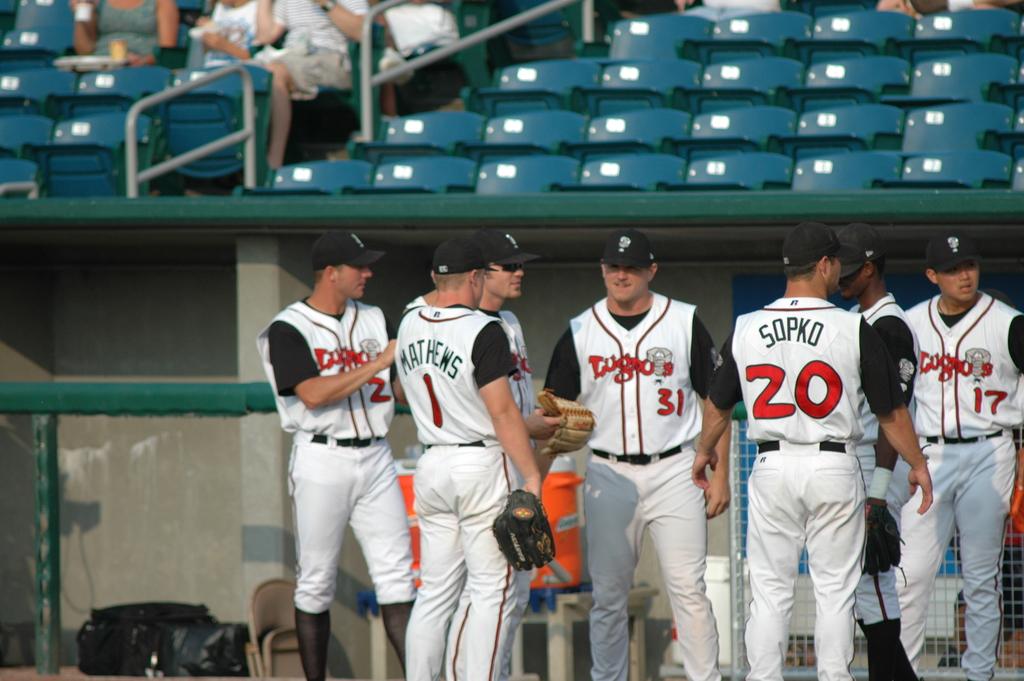What is player number 20's name?
Your answer should be very brief. Sopko. 